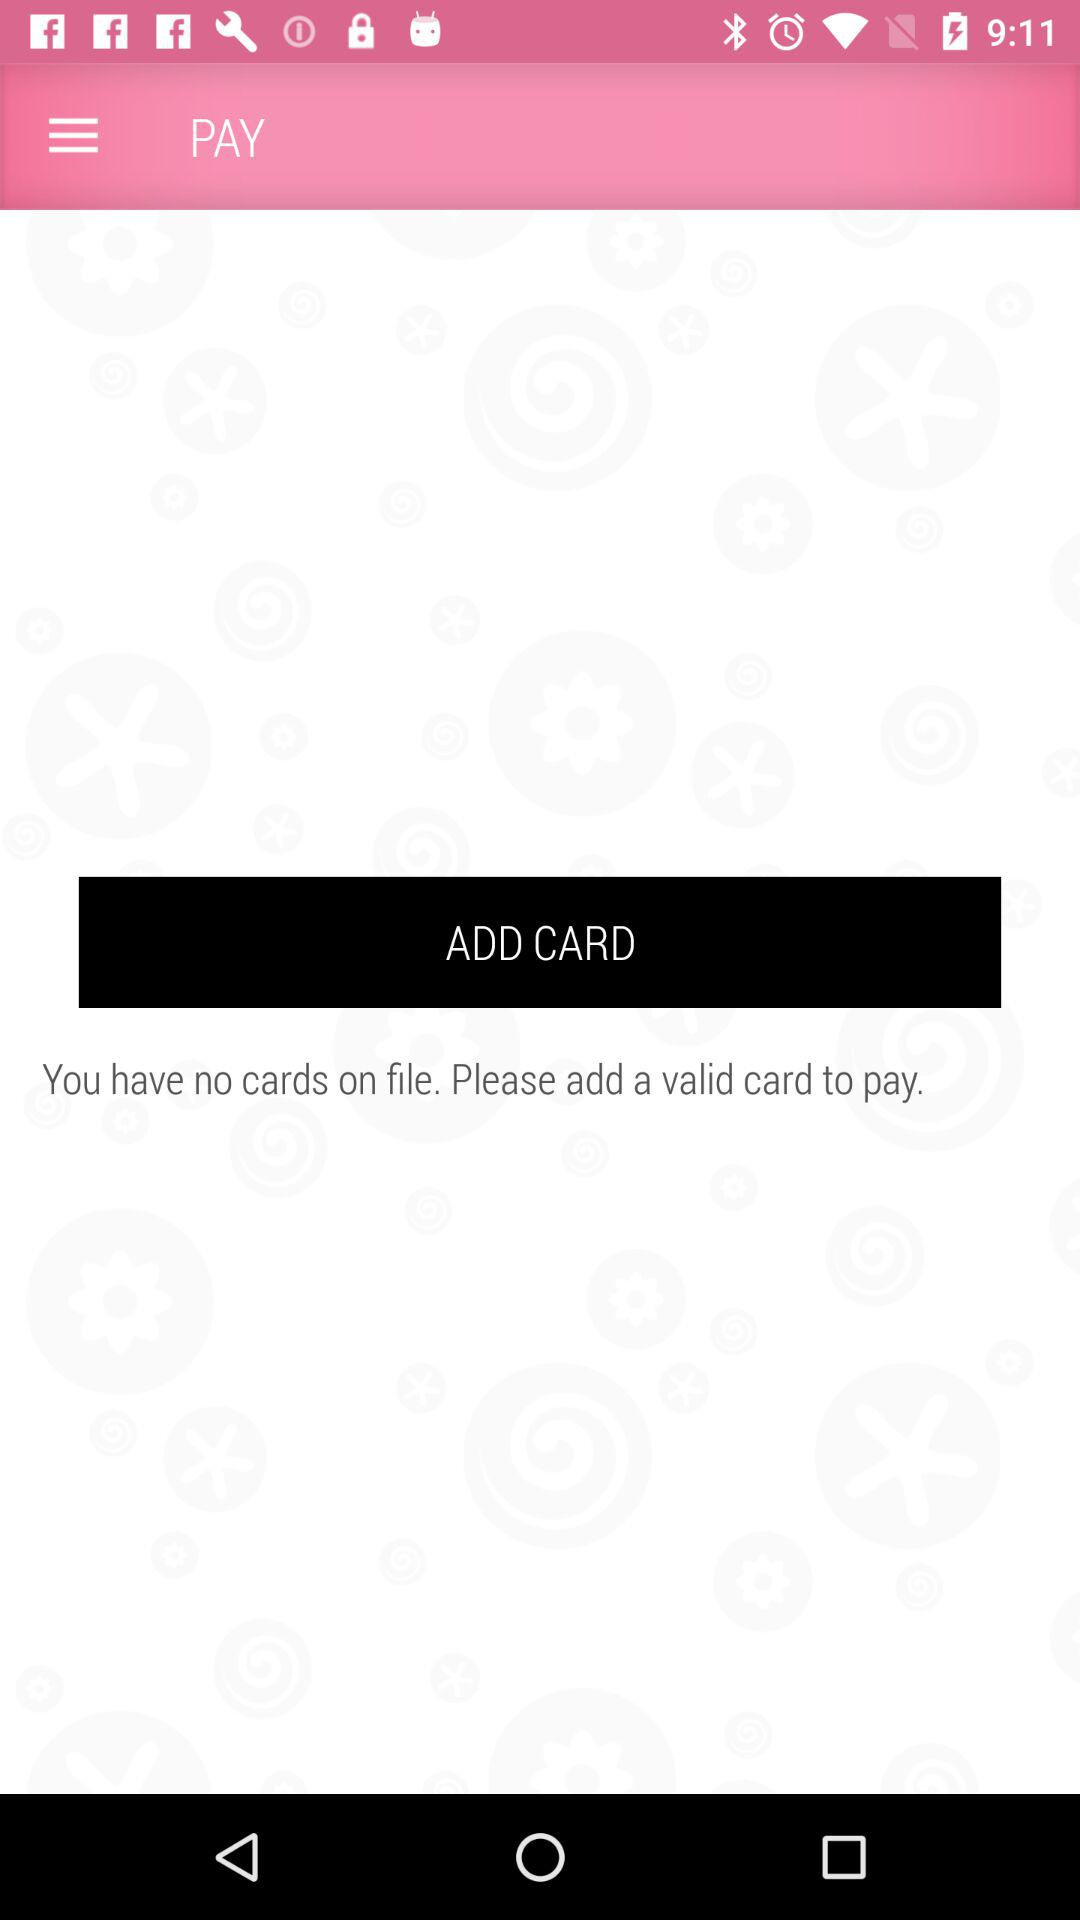What is the app name? The app name is "PAY". 